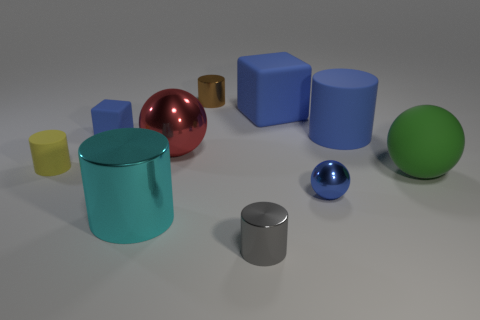Is the tiny block the same color as the big cube?
Give a very brief answer. Yes. What shape is the small shiny object that is behind the red thing?
Your answer should be very brief. Cylinder. There is a cube that is the same size as the gray cylinder; what color is it?
Offer a very short reply. Blue. There is a gray metallic object; does it have the same shape as the large metal thing in front of the yellow rubber cylinder?
Ensure brevity in your answer.  Yes. There is a cylinder right of the small blue thing right of the tiny thing that is in front of the large cyan cylinder; what is it made of?
Keep it short and to the point. Rubber. What number of small objects are purple shiny things or brown metal things?
Provide a short and direct response. 1. How many other objects are there of the same size as the green rubber sphere?
Your response must be concise. 4. There is a tiny blue object right of the tiny brown shiny cylinder; does it have the same shape as the green matte thing?
Offer a terse response. Yes. There is a big matte thing that is the same shape as the large cyan metallic thing; what color is it?
Offer a terse response. Blue. Are there an equal number of rubber cubes that are to the left of the big metal ball and gray metallic cylinders?
Make the answer very short. Yes. 